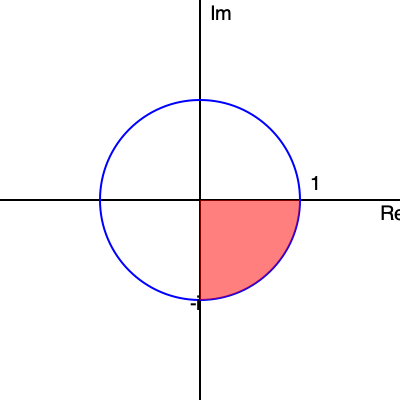Consider the complex function $f(z) = \sqrt{z}$ on the Argand diagram above. The red shaded region represents a possible domain for a branch of this function. What is the range of the argument of $z$ in this domain, and what is the corresponding range of the argument of $f(z)$? Let's approach this step-by-step:

1) The red shaded region is a quarter of the unit circle in the fourth quadrant.

2) For the domain:
   - The argument of $z$ starts at 0 on the positive real axis.
   - It goes clockwise to $-\frac{\pi}{2}$ on the negative imaginary axis.
   - Therefore, the range of $\arg(z)$ is $[0, -\frac{\pi}{2}]$ or $[-\frac{\pi}{2}, 0]$.

3) For the range of $f(z) = \sqrt{z}$:
   - The argument of $\sqrt{z}$ is half the argument of $z$.
   - When $\arg(z) = 0$, $\arg(f(z)) = 0$.
   - When $\arg(z) = -\frac{\pi}{2}$, $\arg(f(z)) = -\frac{\pi}{4}$.
   - Therefore, the range of $\arg(f(z))$ is $[-\frac{\pi}{4}, 0]$.

4) This choice of branch ensures that $f(z)$ is continuous and single-valued in the given domain.
Answer: $\arg(z) \in [-\frac{\pi}{2}, 0]$, $\arg(f(z)) \in [-\frac{\pi}{4}, 0]$ 